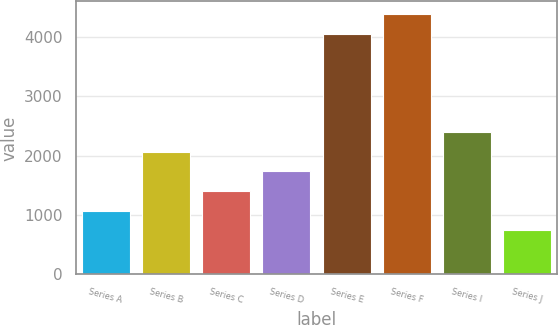<chart> <loc_0><loc_0><loc_500><loc_500><bar_chart><fcel>Series A<fcel>Series B<fcel>Series C<fcel>Series D<fcel>Series E<fcel>Series F<fcel>Series I<fcel>Series J<nl><fcel>1074.76<fcel>2064.64<fcel>1404.72<fcel>1734.68<fcel>4044.44<fcel>4374.4<fcel>2394.61<fcel>744.79<nl></chart> 